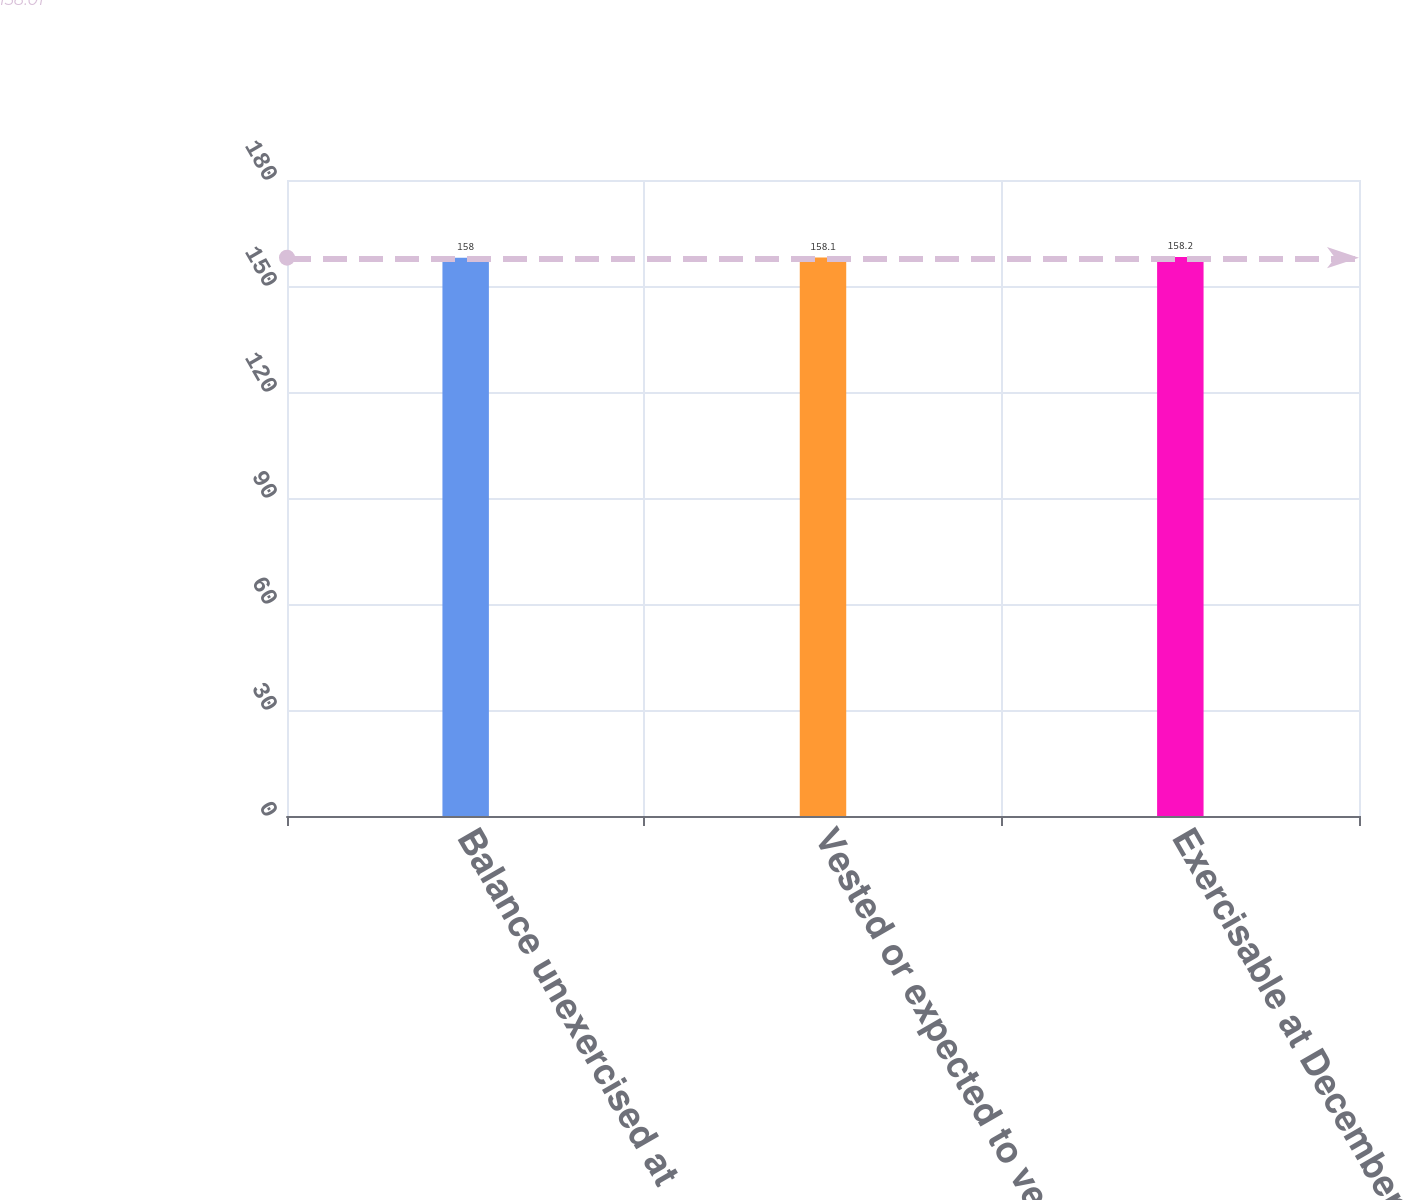Convert chart. <chart><loc_0><loc_0><loc_500><loc_500><bar_chart><fcel>Balance unexercised at<fcel>Vested or expected to vest at<fcel>Exercisable at December 31<nl><fcel>158<fcel>158.1<fcel>158.2<nl></chart> 